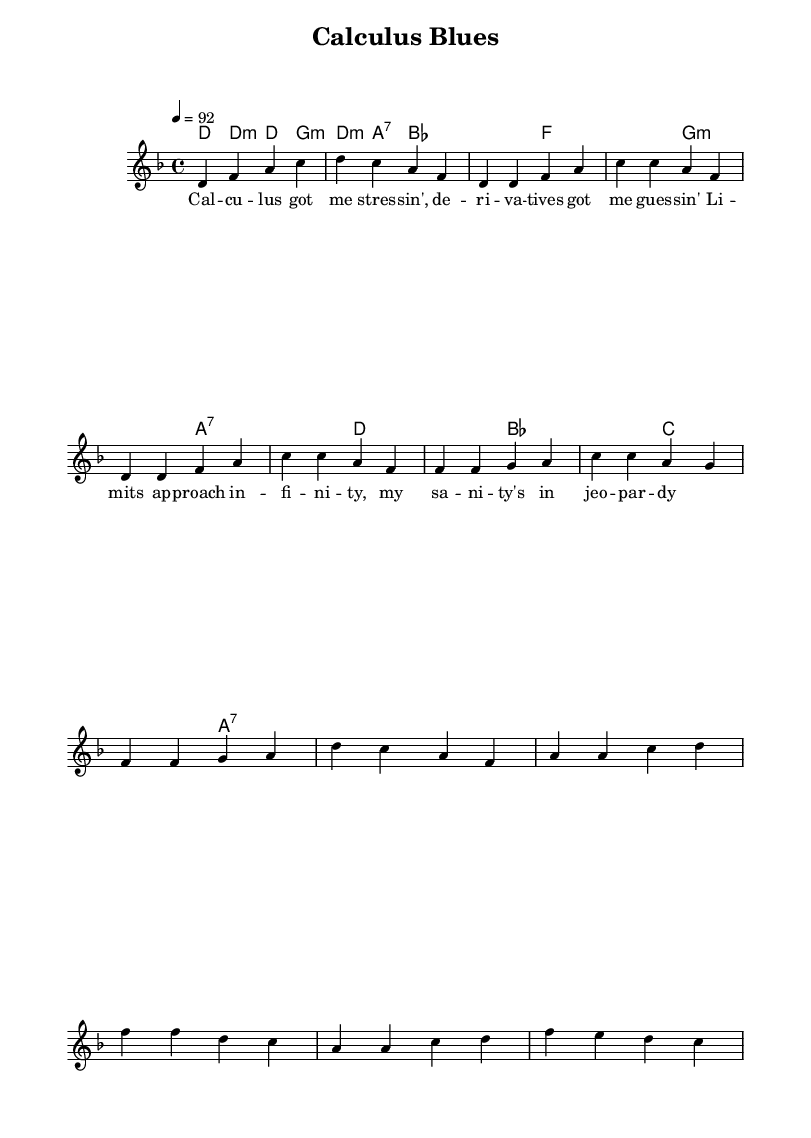What is the key signature of this music? The key signature is D minor, which has one flat (B flat). D minor is shown at the beginning of the staff before the first note.
Answer: D minor What is the time signature of this music? The time signature is 4/4, indicated at the beginning of the score after the key signature. This means there are four beats per measure and the quarter note receives one beat.
Answer: 4/4 What is the tempo marking for this piece? The tempo marking is 92 beats per minute, shown by the number "4 = 92" in the global section. This indicates the pace at which the music should be played.
Answer: 92 How many measures are in the chorus? The chorus consists of four measures, which can be counted from the section labeled as "Chorus" in the score.
Answer: 4 What type of chords are used in the bridge section? The bridge section uses D minor, B flat major, C major, and A seventh chords, which can be identified in the "harmonies" section under the bridge label.
Answer: D minor, B flat, C, A seventh How does the lyrical content reflect the theme of college life? The lyrics mention stress related to calculus, referencing derivatives and limits, which directly relate to college coursework challenges faced by students. This illustrates the humorous take on academic pressure.
Answer: Humor in academics What is the overall mood of the music based on the tempo and key signature? The overall mood is a mix of determination and light-heartedness, encapsulated by the moderate tempo of 92, paired with the somber D minor key that reflects the seriousness of college struggles while maintaining a rhythmic, rap-influenced style.
Answer: Determination and humor 